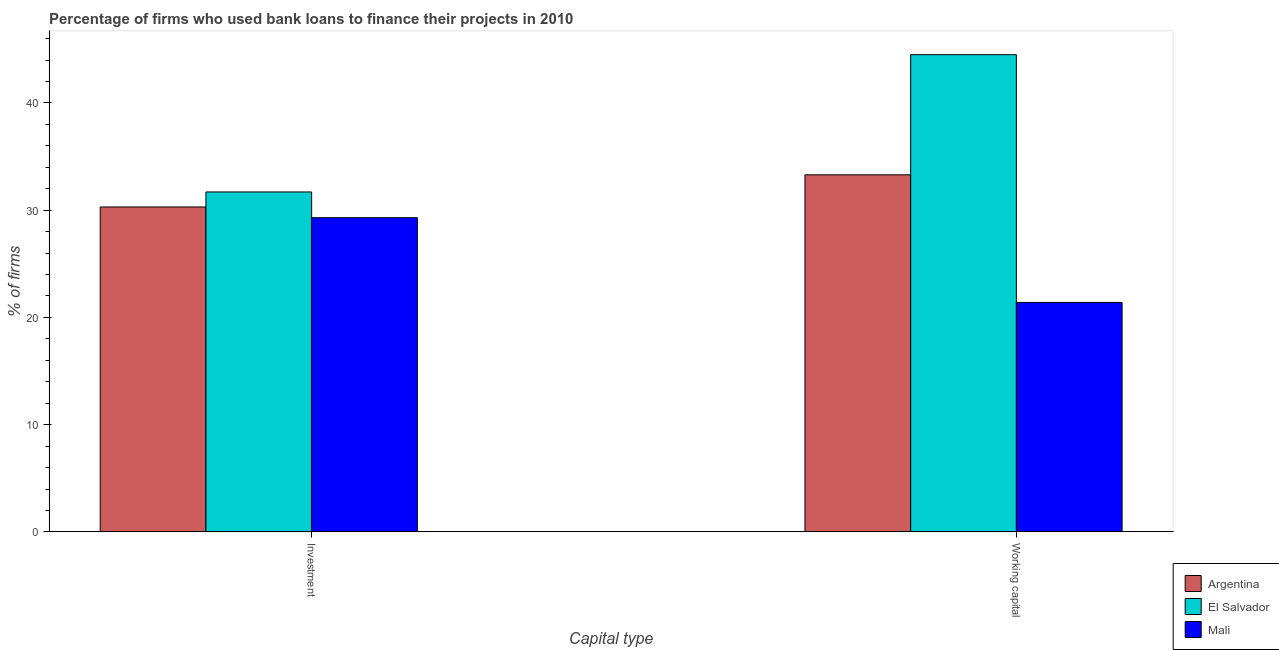How many groups of bars are there?
Give a very brief answer. 2. Are the number of bars per tick equal to the number of legend labels?
Provide a short and direct response. Yes. Are the number of bars on each tick of the X-axis equal?
Your response must be concise. Yes. How many bars are there on the 2nd tick from the left?
Make the answer very short. 3. What is the label of the 1st group of bars from the left?
Offer a very short reply. Investment. What is the percentage of firms using banks to finance investment in Argentina?
Make the answer very short. 30.3. Across all countries, what is the maximum percentage of firms using banks to finance investment?
Offer a very short reply. 31.7. Across all countries, what is the minimum percentage of firms using banks to finance investment?
Your answer should be compact. 29.3. In which country was the percentage of firms using banks to finance investment maximum?
Offer a very short reply. El Salvador. In which country was the percentage of firms using banks to finance investment minimum?
Your answer should be compact. Mali. What is the total percentage of firms using banks to finance investment in the graph?
Your response must be concise. 91.3. What is the difference between the percentage of firms using banks to finance working capital in El Salvador and that in Argentina?
Keep it short and to the point. 11.2. What is the difference between the percentage of firms using banks to finance investment in Argentina and the percentage of firms using banks to finance working capital in Mali?
Provide a succinct answer. 8.9. What is the average percentage of firms using banks to finance working capital per country?
Give a very brief answer. 33.07. In how many countries, is the percentage of firms using banks to finance investment greater than 22 %?
Your answer should be very brief. 3. What is the ratio of the percentage of firms using banks to finance working capital in Argentina to that in Mali?
Offer a terse response. 1.56. Is the percentage of firms using banks to finance investment in Argentina less than that in El Salvador?
Keep it short and to the point. Yes. In how many countries, is the percentage of firms using banks to finance working capital greater than the average percentage of firms using banks to finance working capital taken over all countries?
Your response must be concise. 2. What does the 1st bar from the left in Investment represents?
Ensure brevity in your answer.  Argentina. How many bars are there?
Provide a short and direct response. 6. What is the difference between two consecutive major ticks on the Y-axis?
Your answer should be very brief. 10. Are the values on the major ticks of Y-axis written in scientific E-notation?
Make the answer very short. No. Does the graph contain any zero values?
Your answer should be very brief. No. Where does the legend appear in the graph?
Ensure brevity in your answer.  Bottom right. How many legend labels are there?
Provide a succinct answer. 3. What is the title of the graph?
Keep it short and to the point. Percentage of firms who used bank loans to finance their projects in 2010. Does "Poland" appear as one of the legend labels in the graph?
Offer a very short reply. No. What is the label or title of the X-axis?
Your response must be concise. Capital type. What is the label or title of the Y-axis?
Offer a very short reply. % of firms. What is the % of firms of Argentina in Investment?
Give a very brief answer. 30.3. What is the % of firms in El Salvador in Investment?
Offer a terse response. 31.7. What is the % of firms in Mali in Investment?
Keep it short and to the point. 29.3. What is the % of firms in Argentina in Working capital?
Provide a succinct answer. 33.3. What is the % of firms in El Salvador in Working capital?
Ensure brevity in your answer.  44.5. What is the % of firms in Mali in Working capital?
Provide a succinct answer. 21.4. Across all Capital type, what is the maximum % of firms in Argentina?
Your answer should be very brief. 33.3. Across all Capital type, what is the maximum % of firms of El Salvador?
Your answer should be very brief. 44.5. Across all Capital type, what is the maximum % of firms of Mali?
Provide a short and direct response. 29.3. Across all Capital type, what is the minimum % of firms in Argentina?
Provide a short and direct response. 30.3. Across all Capital type, what is the minimum % of firms of El Salvador?
Offer a very short reply. 31.7. Across all Capital type, what is the minimum % of firms in Mali?
Give a very brief answer. 21.4. What is the total % of firms of Argentina in the graph?
Keep it short and to the point. 63.6. What is the total % of firms in El Salvador in the graph?
Offer a terse response. 76.2. What is the total % of firms of Mali in the graph?
Ensure brevity in your answer.  50.7. What is the difference between the % of firms in Mali in Investment and that in Working capital?
Make the answer very short. 7.9. What is the difference between the % of firms in Argentina in Investment and the % of firms in Mali in Working capital?
Your answer should be very brief. 8.9. What is the difference between the % of firms of El Salvador in Investment and the % of firms of Mali in Working capital?
Offer a terse response. 10.3. What is the average % of firms of Argentina per Capital type?
Make the answer very short. 31.8. What is the average % of firms of El Salvador per Capital type?
Give a very brief answer. 38.1. What is the average % of firms of Mali per Capital type?
Your response must be concise. 25.35. What is the difference between the % of firms of Argentina and % of firms of El Salvador in Investment?
Give a very brief answer. -1.4. What is the difference between the % of firms in Argentina and % of firms in Mali in Investment?
Ensure brevity in your answer.  1. What is the difference between the % of firms of Argentina and % of firms of El Salvador in Working capital?
Ensure brevity in your answer.  -11.2. What is the difference between the % of firms in El Salvador and % of firms in Mali in Working capital?
Provide a short and direct response. 23.1. What is the ratio of the % of firms in Argentina in Investment to that in Working capital?
Provide a short and direct response. 0.91. What is the ratio of the % of firms in El Salvador in Investment to that in Working capital?
Give a very brief answer. 0.71. What is the ratio of the % of firms of Mali in Investment to that in Working capital?
Provide a succinct answer. 1.37. What is the difference between the highest and the second highest % of firms of Argentina?
Keep it short and to the point. 3. What is the difference between the highest and the second highest % of firms in El Salvador?
Your answer should be very brief. 12.8. What is the difference between the highest and the lowest % of firms in Argentina?
Your answer should be compact. 3. What is the difference between the highest and the lowest % of firms of El Salvador?
Make the answer very short. 12.8. What is the difference between the highest and the lowest % of firms of Mali?
Give a very brief answer. 7.9. 